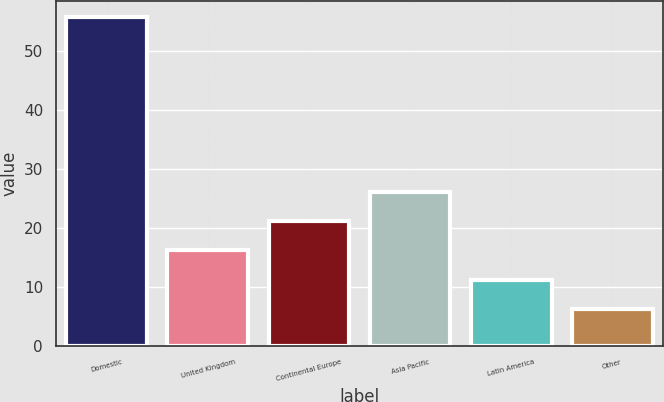Convert chart to OTSL. <chart><loc_0><loc_0><loc_500><loc_500><bar_chart><fcel>Domestic<fcel>United Kingdom<fcel>Continental Europe<fcel>Asia Pacific<fcel>Latin America<fcel>Other<nl><fcel>55.8<fcel>16.2<fcel>21.15<fcel>26.1<fcel>11.25<fcel>6.3<nl></chart> 